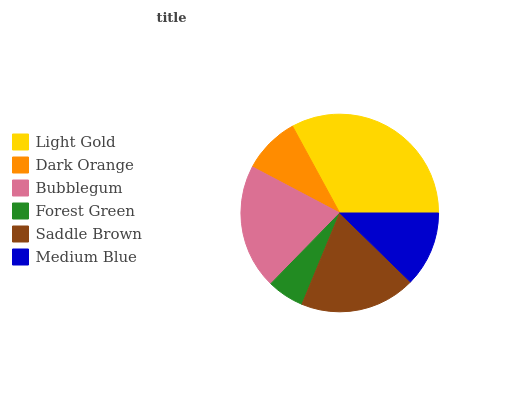Is Forest Green the minimum?
Answer yes or no. Yes. Is Light Gold the maximum?
Answer yes or no. Yes. Is Dark Orange the minimum?
Answer yes or no. No. Is Dark Orange the maximum?
Answer yes or no. No. Is Light Gold greater than Dark Orange?
Answer yes or no. Yes. Is Dark Orange less than Light Gold?
Answer yes or no. Yes. Is Dark Orange greater than Light Gold?
Answer yes or no. No. Is Light Gold less than Dark Orange?
Answer yes or no. No. Is Saddle Brown the high median?
Answer yes or no. Yes. Is Medium Blue the low median?
Answer yes or no. Yes. Is Forest Green the high median?
Answer yes or no. No. Is Saddle Brown the low median?
Answer yes or no. No. 